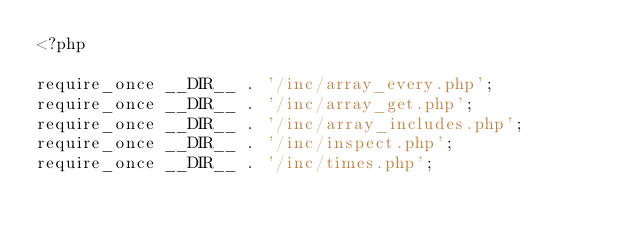<code> <loc_0><loc_0><loc_500><loc_500><_PHP_><?php

require_once __DIR__ . '/inc/array_every.php';
require_once __DIR__ . '/inc/array_get.php';
require_once __DIR__ . '/inc/array_includes.php';
require_once __DIR__ . '/inc/inspect.php';
require_once __DIR__ . '/inc/times.php';
</code> 